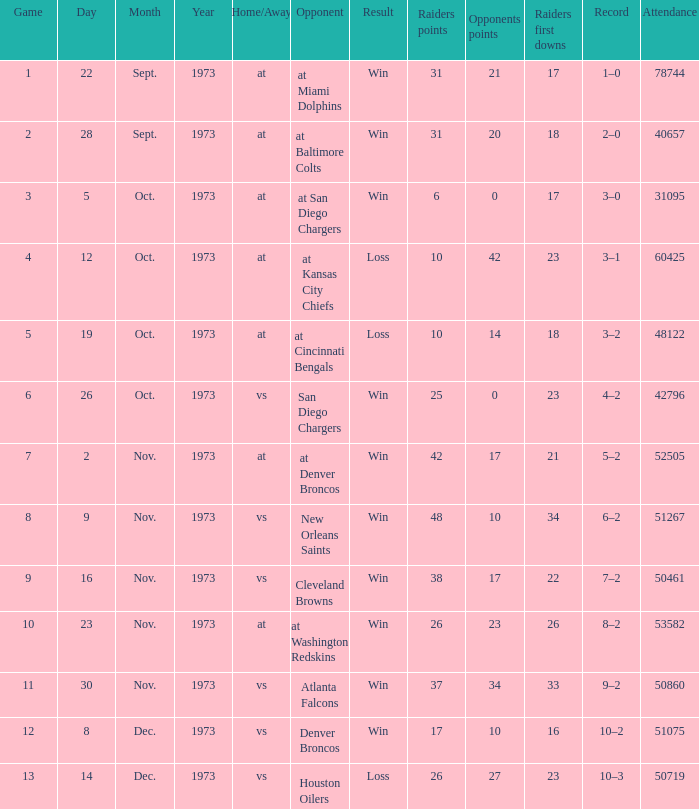Would you be able to parse every entry in this table? {'header': ['Game', 'Day', 'Month', 'Year', 'Home/Away', 'Opponent', 'Result', 'Raiders points', 'Opponents points', 'Raiders first downs', 'Record', 'Attendance'], 'rows': [['1', '22', 'Sept.', '1973', 'at', 'at Miami Dolphins', 'Win', '31', '21', '17', '1–0', '78744'], ['2', '28', 'Sept.', '1973', 'at', 'at Baltimore Colts', 'Win', '31', '20', '18', '2–0', '40657'], ['3', '5', 'Oct.', '1973', 'at', 'at San Diego Chargers', 'Win', '6', '0', '17', '3–0', '31095'], ['4', '12', 'Oct.', '1973', 'at', 'at Kansas City Chiefs', 'Loss', '10', '42', '23', '3–1', '60425'], ['5', '19', 'Oct.', '1973', 'at', 'at Cincinnati Bengals', 'Loss', '10', '14', '18', '3–2', '48122'], ['6', '26', 'Oct.', '1973', 'vs', 'San Diego Chargers', 'Win', '25', '0', '23', '4–2', '42796'], ['7', '2', 'Nov.', '1973', 'at', 'at Denver Broncos', 'Win', '42', '17', '21', '5–2', '52505'], ['8', '9', 'Nov.', '1973', 'vs', 'New Orleans Saints', 'Win', '48', '10', '34', '6–2', '51267'], ['9', '16', 'Nov.', '1973', 'vs', 'Cleveland Browns', 'Win', '38', '17', '22', '7–2', '50461'], ['10', '23', 'Nov.', '1973', 'at', 'at Washington Redskins', 'Win', '26', '23', '26', '8–2', '53582'], ['11', '30', 'Nov.', '1973', 'vs', 'Atlanta Falcons', 'Win', '37', '34', '33', '9–2', '50860'], ['12', '8', 'Dec.', '1973', 'vs', 'Denver Broncos', 'Win', '17', '10', '16', '10–2', '51075'], ['13', '14', 'Dec.', '1973', 'vs', 'Houston Oilers', 'Loss', '26', '27', '23', '10–3', '50719']]} How many different counts of the Raiders first downs are there for the game number 9? 1.0. 